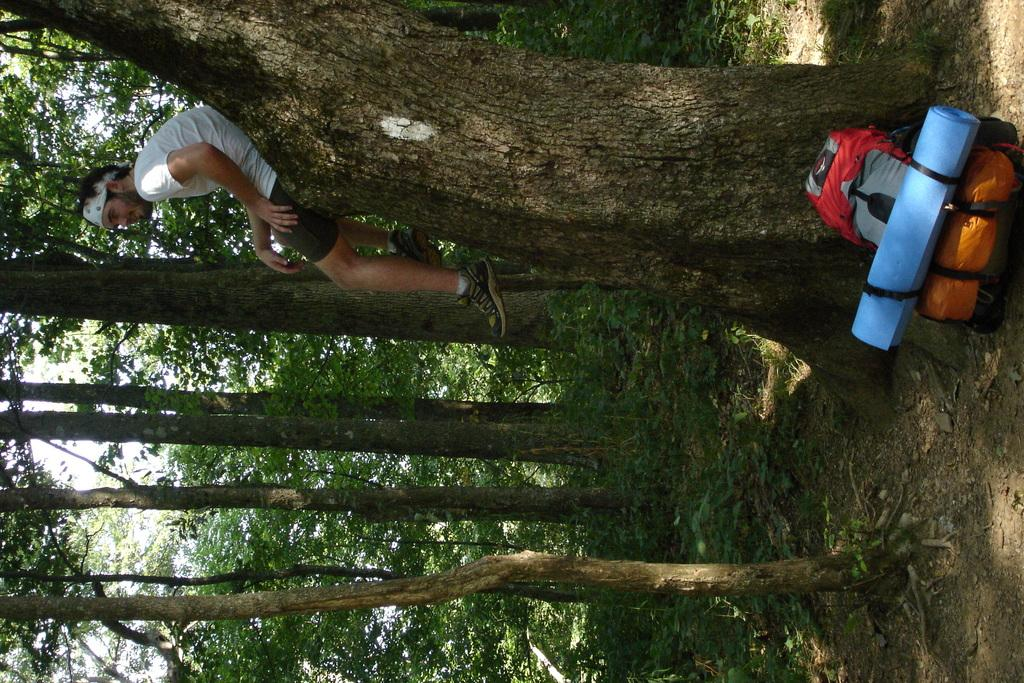What type of vegetation can be seen in the image? There are trees in the image. What is the man in the image doing? The man is sitting on a tree trunk in the image. What objects are on the ground in the image? There are bags on the ground in the image. What is visible at the top of the image? The sky is visible at the top of the image. Is there a bear sitting next to the man in the image? No, there is no bear present in the image. What type of organization is depicted in the image? There is no organization depicted in the image; it features a man sitting on a tree trunk, trees, bags, and the sky. 